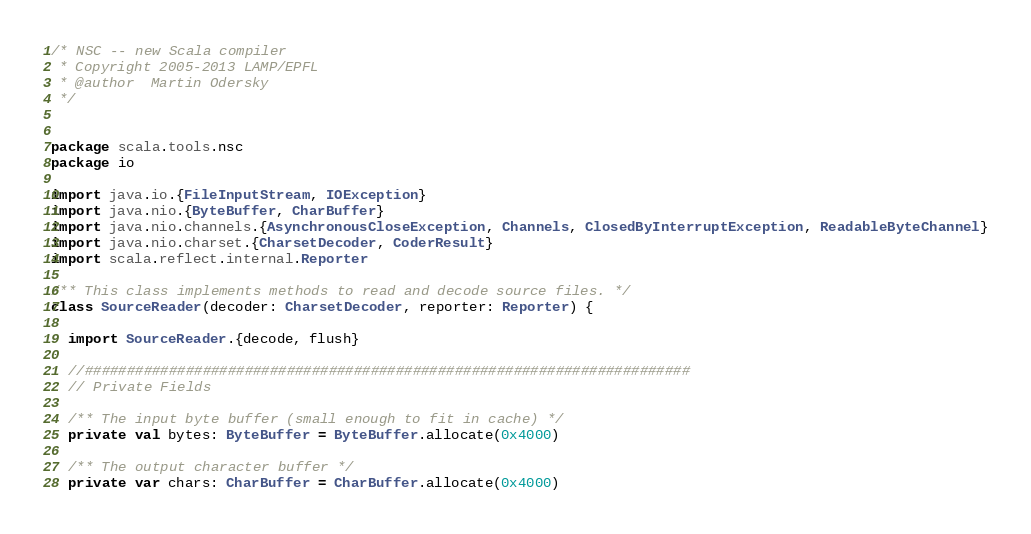Convert code to text. <code><loc_0><loc_0><loc_500><loc_500><_Scala_>/* NSC -- new Scala compiler
 * Copyright 2005-2013 LAMP/EPFL
 * @author  Martin Odersky
 */


package scala.tools.nsc
package io

import java.io.{FileInputStream, IOException}
import java.nio.{ByteBuffer, CharBuffer}
import java.nio.channels.{AsynchronousCloseException, Channels, ClosedByInterruptException, ReadableByteChannel}
import java.nio.charset.{CharsetDecoder, CoderResult}
import scala.reflect.internal.Reporter

/** This class implements methods to read and decode source files. */
class SourceReader(decoder: CharsetDecoder, reporter: Reporter) {

  import SourceReader.{decode, flush}

  //########################################################################
  // Private Fields

  /** The input byte buffer (small enough to fit in cache) */
  private val bytes: ByteBuffer = ByteBuffer.allocate(0x4000)

  /** The output character buffer */
  private var chars: CharBuffer = CharBuffer.allocate(0x4000)
</code> 